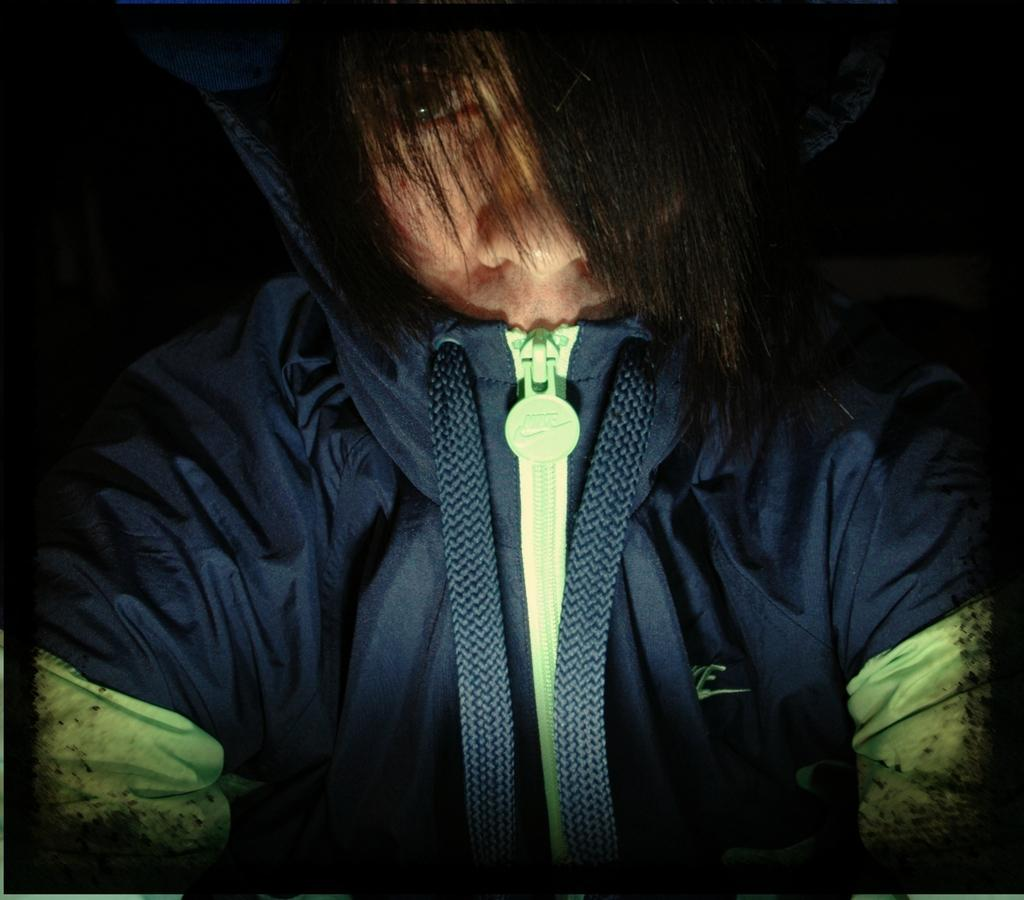What is the main subject of the image? There is a person in the image. What is the person wearing? The person is wearing a jacket. What is the person doing in the image? The person is looking at a picture. How is the person's hair styled in the image? The person's hair falls on their face. What can be observed about the lighting in the image? The background of the image is dark. What type of pets are visible in the image? There are no pets visible in the image. What type of frame is around the picture the person is looking at? The provided facts do not mention a frame around the picture, so it cannot be determined from the image. 